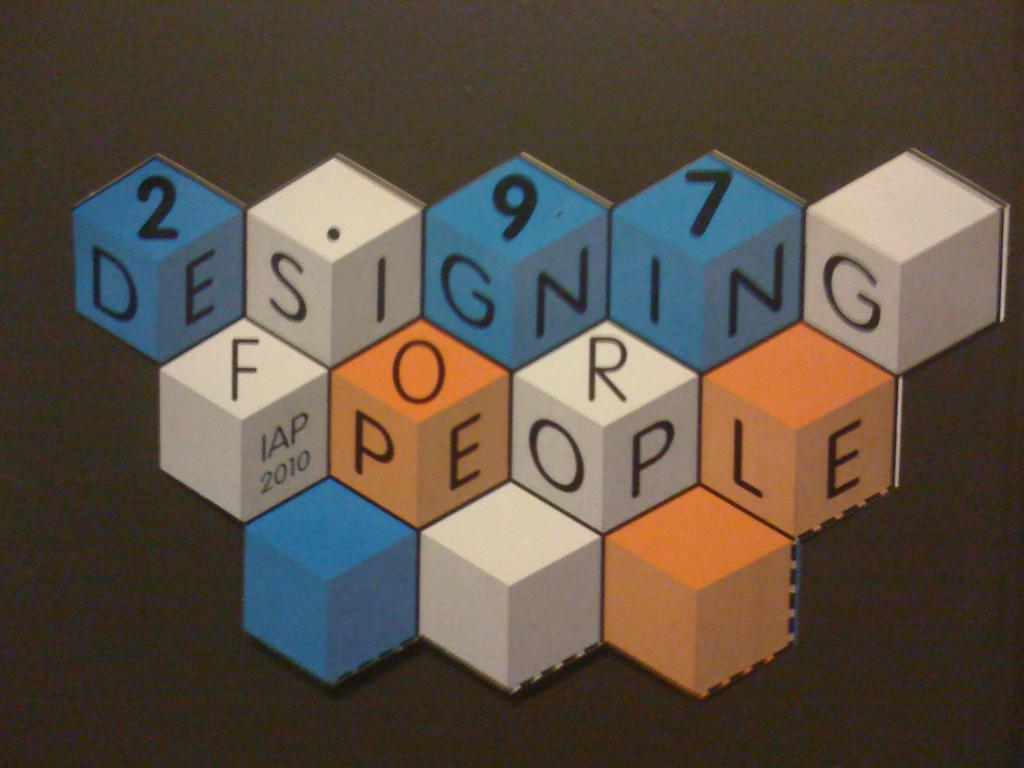<image>
Write a terse but informative summary of the picture. blocks with the words 'designing for people' written across them 